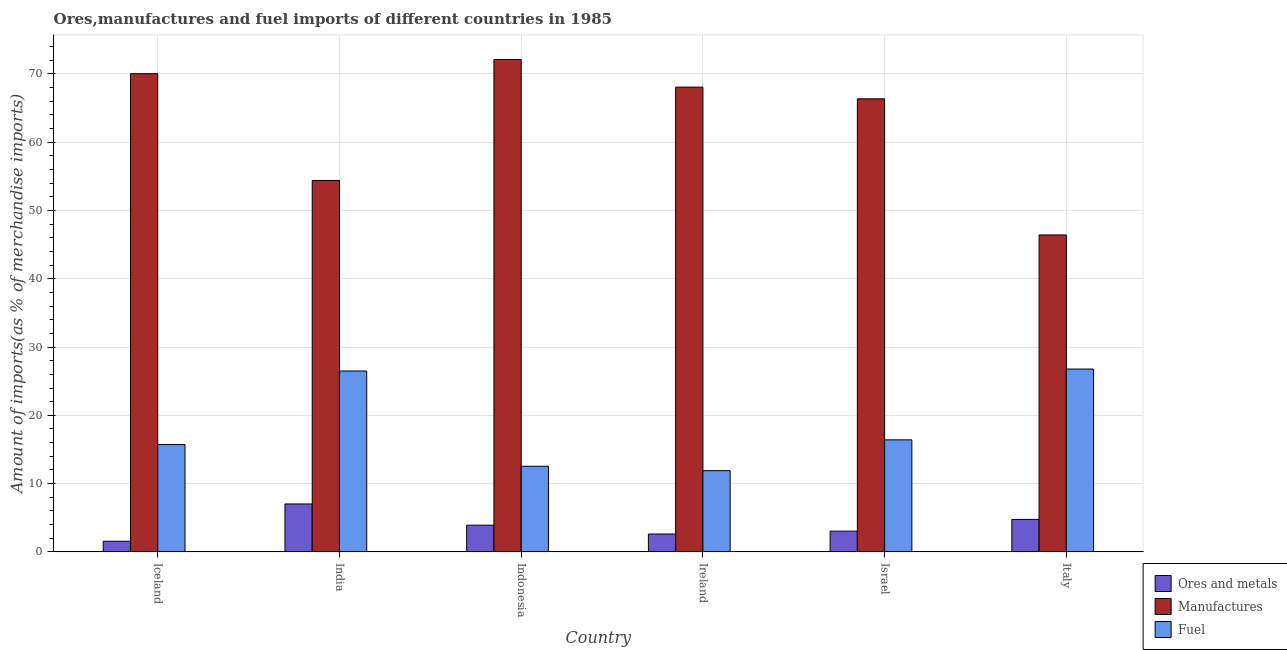How many different coloured bars are there?
Give a very brief answer. 3. Are the number of bars on each tick of the X-axis equal?
Ensure brevity in your answer.  Yes. How many bars are there on the 4th tick from the right?
Your response must be concise. 3. What is the label of the 6th group of bars from the left?
Ensure brevity in your answer.  Italy. What is the percentage of manufactures imports in India?
Your answer should be compact. 54.39. Across all countries, what is the maximum percentage of ores and metals imports?
Provide a succinct answer. 7.02. Across all countries, what is the minimum percentage of manufactures imports?
Your answer should be very brief. 46.41. In which country was the percentage of ores and metals imports maximum?
Offer a very short reply. India. In which country was the percentage of manufactures imports minimum?
Provide a succinct answer. Italy. What is the total percentage of manufactures imports in the graph?
Ensure brevity in your answer.  377.37. What is the difference between the percentage of manufactures imports in India and that in Indonesia?
Offer a very short reply. -17.72. What is the difference between the percentage of ores and metals imports in Italy and the percentage of fuel imports in India?
Your answer should be very brief. -21.74. What is the average percentage of manufactures imports per country?
Make the answer very short. 62.89. What is the difference between the percentage of manufactures imports and percentage of ores and metals imports in Indonesia?
Your answer should be very brief. 68.2. What is the ratio of the percentage of fuel imports in India to that in Indonesia?
Offer a very short reply. 2.11. Is the percentage of fuel imports in India less than that in Israel?
Your answer should be very brief. No. What is the difference between the highest and the second highest percentage of manufactures imports?
Your response must be concise. 2.08. What is the difference between the highest and the lowest percentage of manufactures imports?
Provide a succinct answer. 25.7. Is the sum of the percentage of ores and metals imports in Israel and Italy greater than the maximum percentage of manufactures imports across all countries?
Offer a terse response. No. What does the 3rd bar from the left in Iceland represents?
Make the answer very short. Fuel. What does the 1st bar from the right in Israel represents?
Provide a succinct answer. Fuel. Is it the case that in every country, the sum of the percentage of ores and metals imports and percentage of manufactures imports is greater than the percentage of fuel imports?
Offer a terse response. Yes. How many bars are there?
Offer a very short reply. 18. How many countries are there in the graph?
Ensure brevity in your answer.  6. What is the difference between two consecutive major ticks on the Y-axis?
Provide a short and direct response. 10. Are the values on the major ticks of Y-axis written in scientific E-notation?
Ensure brevity in your answer.  No. Does the graph contain any zero values?
Ensure brevity in your answer.  No. Does the graph contain grids?
Ensure brevity in your answer.  Yes. Where does the legend appear in the graph?
Offer a terse response. Bottom right. How are the legend labels stacked?
Keep it short and to the point. Vertical. What is the title of the graph?
Ensure brevity in your answer.  Ores,manufactures and fuel imports of different countries in 1985. What is the label or title of the X-axis?
Keep it short and to the point. Country. What is the label or title of the Y-axis?
Your response must be concise. Amount of imports(as % of merchandise imports). What is the Amount of imports(as % of merchandise imports) of Ores and metals in Iceland?
Your response must be concise. 1.56. What is the Amount of imports(as % of merchandise imports) in Manufactures in Iceland?
Make the answer very short. 70.03. What is the Amount of imports(as % of merchandise imports) in Fuel in Iceland?
Offer a terse response. 15.71. What is the Amount of imports(as % of merchandise imports) in Ores and metals in India?
Your answer should be compact. 7.02. What is the Amount of imports(as % of merchandise imports) in Manufactures in India?
Your answer should be compact. 54.39. What is the Amount of imports(as % of merchandise imports) of Fuel in India?
Your answer should be compact. 26.49. What is the Amount of imports(as % of merchandise imports) of Ores and metals in Indonesia?
Ensure brevity in your answer.  3.91. What is the Amount of imports(as % of merchandise imports) of Manufactures in Indonesia?
Your answer should be very brief. 72.11. What is the Amount of imports(as % of merchandise imports) of Fuel in Indonesia?
Offer a terse response. 12.54. What is the Amount of imports(as % of merchandise imports) of Ores and metals in Ireland?
Make the answer very short. 2.61. What is the Amount of imports(as % of merchandise imports) of Manufactures in Ireland?
Your response must be concise. 68.07. What is the Amount of imports(as % of merchandise imports) of Fuel in Ireland?
Provide a short and direct response. 11.89. What is the Amount of imports(as % of merchandise imports) of Ores and metals in Israel?
Offer a very short reply. 3.03. What is the Amount of imports(as % of merchandise imports) of Manufactures in Israel?
Your answer should be compact. 66.35. What is the Amount of imports(as % of merchandise imports) in Fuel in Israel?
Provide a succinct answer. 16.41. What is the Amount of imports(as % of merchandise imports) in Ores and metals in Italy?
Offer a very short reply. 4.75. What is the Amount of imports(as % of merchandise imports) of Manufactures in Italy?
Your answer should be compact. 46.41. What is the Amount of imports(as % of merchandise imports) in Fuel in Italy?
Provide a short and direct response. 26.78. Across all countries, what is the maximum Amount of imports(as % of merchandise imports) in Ores and metals?
Offer a terse response. 7.02. Across all countries, what is the maximum Amount of imports(as % of merchandise imports) in Manufactures?
Your response must be concise. 72.11. Across all countries, what is the maximum Amount of imports(as % of merchandise imports) of Fuel?
Ensure brevity in your answer.  26.78. Across all countries, what is the minimum Amount of imports(as % of merchandise imports) of Ores and metals?
Offer a terse response. 1.56. Across all countries, what is the minimum Amount of imports(as % of merchandise imports) in Manufactures?
Offer a terse response. 46.41. Across all countries, what is the minimum Amount of imports(as % of merchandise imports) of Fuel?
Make the answer very short. 11.89. What is the total Amount of imports(as % of merchandise imports) in Ores and metals in the graph?
Your answer should be compact. 22.89. What is the total Amount of imports(as % of merchandise imports) of Manufactures in the graph?
Keep it short and to the point. 377.37. What is the total Amount of imports(as % of merchandise imports) in Fuel in the graph?
Provide a short and direct response. 109.82. What is the difference between the Amount of imports(as % of merchandise imports) of Ores and metals in Iceland and that in India?
Your response must be concise. -5.46. What is the difference between the Amount of imports(as % of merchandise imports) in Manufactures in Iceland and that in India?
Your answer should be compact. 15.64. What is the difference between the Amount of imports(as % of merchandise imports) in Fuel in Iceland and that in India?
Offer a terse response. -10.78. What is the difference between the Amount of imports(as % of merchandise imports) of Ores and metals in Iceland and that in Indonesia?
Ensure brevity in your answer.  -2.35. What is the difference between the Amount of imports(as % of merchandise imports) in Manufactures in Iceland and that in Indonesia?
Provide a short and direct response. -2.08. What is the difference between the Amount of imports(as % of merchandise imports) of Fuel in Iceland and that in Indonesia?
Ensure brevity in your answer.  3.18. What is the difference between the Amount of imports(as % of merchandise imports) of Ores and metals in Iceland and that in Ireland?
Your answer should be very brief. -1.06. What is the difference between the Amount of imports(as % of merchandise imports) in Manufactures in Iceland and that in Ireland?
Ensure brevity in your answer.  1.96. What is the difference between the Amount of imports(as % of merchandise imports) in Fuel in Iceland and that in Ireland?
Offer a very short reply. 3.82. What is the difference between the Amount of imports(as % of merchandise imports) of Ores and metals in Iceland and that in Israel?
Make the answer very short. -1.48. What is the difference between the Amount of imports(as % of merchandise imports) of Manufactures in Iceland and that in Israel?
Your answer should be very brief. 3.68. What is the difference between the Amount of imports(as % of merchandise imports) of Fuel in Iceland and that in Israel?
Make the answer very short. -0.69. What is the difference between the Amount of imports(as % of merchandise imports) of Ores and metals in Iceland and that in Italy?
Provide a short and direct response. -3.2. What is the difference between the Amount of imports(as % of merchandise imports) in Manufactures in Iceland and that in Italy?
Provide a succinct answer. 23.62. What is the difference between the Amount of imports(as % of merchandise imports) in Fuel in Iceland and that in Italy?
Offer a terse response. -11.06. What is the difference between the Amount of imports(as % of merchandise imports) of Ores and metals in India and that in Indonesia?
Provide a succinct answer. 3.11. What is the difference between the Amount of imports(as % of merchandise imports) of Manufactures in India and that in Indonesia?
Make the answer very short. -17.72. What is the difference between the Amount of imports(as % of merchandise imports) in Fuel in India and that in Indonesia?
Give a very brief answer. 13.95. What is the difference between the Amount of imports(as % of merchandise imports) of Ores and metals in India and that in Ireland?
Offer a very short reply. 4.4. What is the difference between the Amount of imports(as % of merchandise imports) in Manufactures in India and that in Ireland?
Provide a succinct answer. -13.68. What is the difference between the Amount of imports(as % of merchandise imports) of Fuel in India and that in Ireland?
Ensure brevity in your answer.  14.6. What is the difference between the Amount of imports(as % of merchandise imports) of Ores and metals in India and that in Israel?
Your response must be concise. 3.98. What is the difference between the Amount of imports(as % of merchandise imports) of Manufactures in India and that in Israel?
Your answer should be compact. -11.96. What is the difference between the Amount of imports(as % of merchandise imports) in Fuel in India and that in Israel?
Ensure brevity in your answer.  10.09. What is the difference between the Amount of imports(as % of merchandise imports) in Ores and metals in India and that in Italy?
Offer a terse response. 2.26. What is the difference between the Amount of imports(as % of merchandise imports) of Manufactures in India and that in Italy?
Provide a succinct answer. 7.98. What is the difference between the Amount of imports(as % of merchandise imports) in Fuel in India and that in Italy?
Keep it short and to the point. -0.28. What is the difference between the Amount of imports(as % of merchandise imports) in Ores and metals in Indonesia and that in Ireland?
Your response must be concise. 1.3. What is the difference between the Amount of imports(as % of merchandise imports) of Manufactures in Indonesia and that in Ireland?
Keep it short and to the point. 4.04. What is the difference between the Amount of imports(as % of merchandise imports) in Fuel in Indonesia and that in Ireland?
Provide a succinct answer. 0.65. What is the difference between the Amount of imports(as % of merchandise imports) in Ores and metals in Indonesia and that in Israel?
Your answer should be very brief. 0.88. What is the difference between the Amount of imports(as % of merchandise imports) of Manufactures in Indonesia and that in Israel?
Offer a very short reply. 5.76. What is the difference between the Amount of imports(as % of merchandise imports) of Fuel in Indonesia and that in Israel?
Your response must be concise. -3.87. What is the difference between the Amount of imports(as % of merchandise imports) in Ores and metals in Indonesia and that in Italy?
Give a very brief answer. -0.84. What is the difference between the Amount of imports(as % of merchandise imports) in Manufactures in Indonesia and that in Italy?
Give a very brief answer. 25.7. What is the difference between the Amount of imports(as % of merchandise imports) of Fuel in Indonesia and that in Italy?
Provide a short and direct response. -14.24. What is the difference between the Amount of imports(as % of merchandise imports) in Ores and metals in Ireland and that in Israel?
Your response must be concise. -0.42. What is the difference between the Amount of imports(as % of merchandise imports) of Manufactures in Ireland and that in Israel?
Your answer should be very brief. 1.72. What is the difference between the Amount of imports(as % of merchandise imports) in Fuel in Ireland and that in Israel?
Ensure brevity in your answer.  -4.51. What is the difference between the Amount of imports(as % of merchandise imports) in Ores and metals in Ireland and that in Italy?
Keep it short and to the point. -2.14. What is the difference between the Amount of imports(as % of merchandise imports) of Manufactures in Ireland and that in Italy?
Your response must be concise. 21.65. What is the difference between the Amount of imports(as % of merchandise imports) of Fuel in Ireland and that in Italy?
Keep it short and to the point. -14.88. What is the difference between the Amount of imports(as % of merchandise imports) in Ores and metals in Israel and that in Italy?
Provide a short and direct response. -1.72. What is the difference between the Amount of imports(as % of merchandise imports) in Manufactures in Israel and that in Italy?
Your answer should be very brief. 19.94. What is the difference between the Amount of imports(as % of merchandise imports) in Fuel in Israel and that in Italy?
Your answer should be compact. -10.37. What is the difference between the Amount of imports(as % of merchandise imports) of Ores and metals in Iceland and the Amount of imports(as % of merchandise imports) of Manufactures in India?
Your answer should be very brief. -52.84. What is the difference between the Amount of imports(as % of merchandise imports) of Ores and metals in Iceland and the Amount of imports(as % of merchandise imports) of Fuel in India?
Provide a succinct answer. -24.94. What is the difference between the Amount of imports(as % of merchandise imports) in Manufactures in Iceland and the Amount of imports(as % of merchandise imports) in Fuel in India?
Make the answer very short. 43.54. What is the difference between the Amount of imports(as % of merchandise imports) of Ores and metals in Iceland and the Amount of imports(as % of merchandise imports) of Manufactures in Indonesia?
Your answer should be compact. -70.56. What is the difference between the Amount of imports(as % of merchandise imports) in Ores and metals in Iceland and the Amount of imports(as % of merchandise imports) in Fuel in Indonesia?
Provide a succinct answer. -10.98. What is the difference between the Amount of imports(as % of merchandise imports) of Manufactures in Iceland and the Amount of imports(as % of merchandise imports) of Fuel in Indonesia?
Ensure brevity in your answer.  57.49. What is the difference between the Amount of imports(as % of merchandise imports) in Ores and metals in Iceland and the Amount of imports(as % of merchandise imports) in Manufactures in Ireland?
Your answer should be very brief. -66.51. What is the difference between the Amount of imports(as % of merchandise imports) in Ores and metals in Iceland and the Amount of imports(as % of merchandise imports) in Fuel in Ireland?
Your answer should be very brief. -10.34. What is the difference between the Amount of imports(as % of merchandise imports) of Manufactures in Iceland and the Amount of imports(as % of merchandise imports) of Fuel in Ireland?
Keep it short and to the point. 58.14. What is the difference between the Amount of imports(as % of merchandise imports) in Ores and metals in Iceland and the Amount of imports(as % of merchandise imports) in Manufactures in Israel?
Your answer should be compact. -64.8. What is the difference between the Amount of imports(as % of merchandise imports) in Ores and metals in Iceland and the Amount of imports(as % of merchandise imports) in Fuel in Israel?
Provide a succinct answer. -14.85. What is the difference between the Amount of imports(as % of merchandise imports) in Manufactures in Iceland and the Amount of imports(as % of merchandise imports) in Fuel in Israel?
Ensure brevity in your answer.  53.62. What is the difference between the Amount of imports(as % of merchandise imports) in Ores and metals in Iceland and the Amount of imports(as % of merchandise imports) in Manufactures in Italy?
Make the answer very short. -44.86. What is the difference between the Amount of imports(as % of merchandise imports) in Ores and metals in Iceland and the Amount of imports(as % of merchandise imports) in Fuel in Italy?
Keep it short and to the point. -25.22. What is the difference between the Amount of imports(as % of merchandise imports) in Manufactures in Iceland and the Amount of imports(as % of merchandise imports) in Fuel in Italy?
Provide a short and direct response. 43.25. What is the difference between the Amount of imports(as % of merchandise imports) of Ores and metals in India and the Amount of imports(as % of merchandise imports) of Manufactures in Indonesia?
Your answer should be very brief. -65.09. What is the difference between the Amount of imports(as % of merchandise imports) in Ores and metals in India and the Amount of imports(as % of merchandise imports) in Fuel in Indonesia?
Your answer should be very brief. -5.52. What is the difference between the Amount of imports(as % of merchandise imports) in Manufactures in India and the Amount of imports(as % of merchandise imports) in Fuel in Indonesia?
Your response must be concise. 41.85. What is the difference between the Amount of imports(as % of merchandise imports) in Ores and metals in India and the Amount of imports(as % of merchandise imports) in Manufactures in Ireland?
Provide a short and direct response. -61.05. What is the difference between the Amount of imports(as % of merchandise imports) of Ores and metals in India and the Amount of imports(as % of merchandise imports) of Fuel in Ireland?
Provide a succinct answer. -4.88. What is the difference between the Amount of imports(as % of merchandise imports) in Manufactures in India and the Amount of imports(as % of merchandise imports) in Fuel in Ireland?
Keep it short and to the point. 42.5. What is the difference between the Amount of imports(as % of merchandise imports) of Ores and metals in India and the Amount of imports(as % of merchandise imports) of Manufactures in Israel?
Keep it short and to the point. -59.34. What is the difference between the Amount of imports(as % of merchandise imports) in Ores and metals in India and the Amount of imports(as % of merchandise imports) in Fuel in Israel?
Keep it short and to the point. -9.39. What is the difference between the Amount of imports(as % of merchandise imports) in Manufactures in India and the Amount of imports(as % of merchandise imports) in Fuel in Israel?
Offer a very short reply. 37.99. What is the difference between the Amount of imports(as % of merchandise imports) in Ores and metals in India and the Amount of imports(as % of merchandise imports) in Manufactures in Italy?
Offer a very short reply. -39.4. What is the difference between the Amount of imports(as % of merchandise imports) of Ores and metals in India and the Amount of imports(as % of merchandise imports) of Fuel in Italy?
Make the answer very short. -19.76. What is the difference between the Amount of imports(as % of merchandise imports) in Manufactures in India and the Amount of imports(as % of merchandise imports) in Fuel in Italy?
Provide a short and direct response. 27.62. What is the difference between the Amount of imports(as % of merchandise imports) of Ores and metals in Indonesia and the Amount of imports(as % of merchandise imports) of Manufactures in Ireland?
Offer a very short reply. -64.16. What is the difference between the Amount of imports(as % of merchandise imports) in Ores and metals in Indonesia and the Amount of imports(as % of merchandise imports) in Fuel in Ireland?
Provide a succinct answer. -7.98. What is the difference between the Amount of imports(as % of merchandise imports) of Manufactures in Indonesia and the Amount of imports(as % of merchandise imports) of Fuel in Ireland?
Your response must be concise. 60.22. What is the difference between the Amount of imports(as % of merchandise imports) of Ores and metals in Indonesia and the Amount of imports(as % of merchandise imports) of Manufactures in Israel?
Provide a short and direct response. -62.44. What is the difference between the Amount of imports(as % of merchandise imports) in Ores and metals in Indonesia and the Amount of imports(as % of merchandise imports) in Fuel in Israel?
Make the answer very short. -12.5. What is the difference between the Amount of imports(as % of merchandise imports) of Manufactures in Indonesia and the Amount of imports(as % of merchandise imports) of Fuel in Israel?
Ensure brevity in your answer.  55.71. What is the difference between the Amount of imports(as % of merchandise imports) in Ores and metals in Indonesia and the Amount of imports(as % of merchandise imports) in Manufactures in Italy?
Offer a terse response. -42.5. What is the difference between the Amount of imports(as % of merchandise imports) in Ores and metals in Indonesia and the Amount of imports(as % of merchandise imports) in Fuel in Italy?
Provide a succinct answer. -22.87. What is the difference between the Amount of imports(as % of merchandise imports) in Manufactures in Indonesia and the Amount of imports(as % of merchandise imports) in Fuel in Italy?
Your answer should be compact. 45.34. What is the difference between the Amount of imports(as % of merchandise imports) in Ores and metals in Ireland and the Amount of imports(as % of merchandise imports) in Manufactures in Israel?
Provide a succinct answer. -63.74. What is the difference between the Amount of imports(as % of merchandise imports) in Ores and metals in Ireland and the Amount of imports(as % of merchandise imports) in Fuel in Israel?
Offer a terse response. -13.79. What is the difference between the Amount of imports(as % of merchandise imports) of Manufactures in Ireland and the Amount of imports(as % of merchandise imports) of Fuel in Israel?
Ensure brevity in your answer.  51.66. What is the difference between the Amount of imports(as % of merchandise imports) of Ores and metals in Ireland and the Amount of imports(as % of merchandise imports) of Manufactures in Italy?
Your answer should be very brief. -43.8. What is the difference between the Amount of imports(as % of merchandise imports) in Ores and metals in Ireland and the Amount of imports(as % of merchandise imports) in Fuel in Italy?
Offer a very short reply. -24.16. What is the difference between the Amount of imports(as % of merchandise imports) in Manufactures in Ireland and the Amount of imports(as % of merchandise imports) in Fuel in Italy?
Your response must be concise. 41.29. What is the difference between the Amount of imports(as % of merchandise imports) in Ores and metals in Israel and the Amount of imports(as % of merchandise imports) in Manufactures in Italy?
Ensure brevity in your answer.  -43.38. What is the difference between the Amount of imports(as % of merchandise imports) in Ores and metals in Israel and the Amount of imports(as % of merchandise imports) in Fuel in Italy?
Offer a terse response. -23.74. What is the difference between the Amount of imports(as % of merchandise imports) of Manufactures in Israel and the Amount of imports(as % of merchandise imports) of Fuel in Italy?
Keep it short and to the point. 39.58. What is the average Amount of imports(as % of merchandise imports) in Ores and metals per country?
Give a very brief answer. 3.81. What is the average Amount of imports(as % of merchandise imports) of Manufactures per country?
Ensure brevity in your answer.  62.89. What is the average Amount of imports(as % of merchandise imports) of Fuel per country?
Provide a succinct answer. 18.3. What is the difference between the Amount of imports(as % of merchandise imports) of Ores and metals and Amount of imports(as % of merchandise imports) of Manufactures in Iceland?
Give a very brief answer. -68.47. What is the difference between the Amount of imports(as % of merchandise imports) of Ores and metals and Amount of imports(as % of merchandise imports) of Fuel in Iceland?
Offer a very short reply. -14.16. What is the difference between the Amount of imports(as % of merchandise imports) of Manufactures and Amount of imports(as % of merchandise imports) of Fuel in Iceland?
Your answer should be compact. 54.31. What is the difference between the Amount of imports(as % of merchandise imports) in Ores and metals and Amount of imports(as % of merchandise imports) in Manufactures in India?
Provide a succinct answer. -47.38. What is the difference between the Amount of imports(as % of merchandise imports) of Ores and metals and Amount of imports(as % of merchandise imports) of Fuel in India?
Provide a succinct answer. -19.47. What is the difference between the Amount of imports(as % of merchandise imports) in Manufactures and Amount of imports(as % of merchandise imports) in Fuel in India?
Keep it short and to the point. 27.9. What is the difference between the Amount of imports(as % of merchandise imports) in Ores and metals and Amount of imports(as % of merchandise imports) in Manufactures in Indonesia?
Provide a succinct answer. -68.2. What is the difference between the Amount of imports(as % of merchandise imports) in Ores and metals and Amount of imports(as % of merchandise imports) in Fuel in Indonesia?
Provide a succinct answer. -8.63. What is the difference between the Amount of imports(as % of merchandise imports) of Manufactures and Amount of imports(as % of merchandise imports) of Fuel in Indonesia?
Provide a short and direct response. 59.57. What is the difference between the Amount of imports(as % of merchandise imports) of Ores and metals and Amount of imports(as % of merchandise imports) of Manufactures in Ireland?
Your response must be concise. -65.45. What is the difference between the Amount of imports(as % of merchandise imports) of Ores and metals and Amount of imports(as % of merchandise imports) of Fuel in Ireland?
Your response must be concise. -9.28. What is the difference between the Amount of imports(as % of merchandise imports) of Manufactures and Amount of imports(as % of merchandise imports) of Fuel in Ireland?
Keep it short and to the point. 56.18. What is the difference between the Amount of imports(as % of merchandise imports) of Ores and metals and Amount of imports(as % of merchandise imports) of Manufactures in Israel?
Provide a short and direct response. -63.32. What is the difference between the Amount of imports(as % of merchandise imports) of Ores and metals and Amount of imports(as % of merchandise imports) of Fuel in Israel?
Your response must be concise. -13.37. What is the difference between the Amount of imports(as % of merchandise imports) of Manufactures and Amount of imports(as % of merchandise imports) of Fuel in Israel?
Offer a very short reply. 49.95. What is the difference between the Amount of imports(as % of merchandise imports) in Ores and metals and Amount of imports(as % of merchandise imports) in Manufactures in Italy?
Your answer should be compact. -41.66. What is the difference between the Amount of imports(as % of merchandise imports) of Ores and metals and Amount of imports(as % of merchandise imports) of Fuel in Italy?
Offer a very short reply. -22.02. What is the difference between the Amount of imports(as % of merchandise imports) of Manufactures and Amount of imports(as % of merchandise imports) of Fuel in Italy?
Keep it short and to the point. 19.64. What is the ratio of the Amount of imports(as % of merchandise imports) of Ores and metals in Iceland to that in India?
Keep it short and to the point. 0.22. What is the ratio of the Amount of imports(as % of merchandise imports) of Manufactures in Iceland to that in India?
Ensure brevity in your answer.  1.29. What is the ratio of the Amount of imports(as % of merchandise imports) in Fuel in Iceland to that in India?
Keep it short and to the point. 0.59. What is the ratio of the Amount of imports(as % of merchandise imports) of Ores and metals in Iceland to that in Indonesia?
Your answer should be very brief. 0.4. What is the ratio of the Amount of imports(as % of merchandise imports) of Manufactures in Iceland to that in Indonesia?
Keep it short and to the point. 0.97. What is the ratio of the Amount of imports(as % of merchandise imports) of Fuel in Iceland to that in Indonesia?
Make the answer very short. 1.25. What is the ratio of the Amount of imports(as % of merchandise imports) of Ores and metals in Iceland to that in Ireland?
Your answer should be compact. 0.6. What is the ratio of the Amount of imports(as % of merchandise imports) in Manufactures in Iceland to that in Ireland?
Ensure brevity in your answer.  1.03. What is the ratio of the Amount of imports(as % of merchandise imports) of Fuel in Iceland to that in Ireland?
Make the answer very short. 1.32. What is the ratio of the Amount of imports(as % of merchandise imports) in Ores and metals in Iceland to that in Israel?
Offer a terse response. 0.51. What is the ratio of the Amount of imports(as % of merchandise imports) of Manufactures in Iceland to that in Israel?
Ensure brevity in your answer.  1.06. What is the ratio of the Amount of imports(as % of merchandise imports) of Fuel in Iceland to that in Israel?
Make the answer very short. 0.96. What is the ratio of the Amount of imports(as % of merchandise imports) of Ores and metals in Iceland to that in Italy?
Provide a succinct answer. 0.33. What is the ratio of the Amount of imports(as % of merchandise imports) in Manufactures in Iceland to that in Italy?
Provide a succinct answer. 1.51. What is the ratio of the Amount of imports(as % of merchandise imports) of Fuel in Iceland to that in Italy?
Give a very brief answer. 0.59. What is the ratio of the Amount of imports(as % of merchandise imports) of Ores and metals in India to that in Indonesia?
Your response must be concise. 1.79. What is the ratio of the Amount of imports(as % of merchandise imports) in Manufactures in India to that in Indonesia?
Your response must be concise. 0.75. What is the ratio of the Amount of imports(as % of merchandise imports) of Fuel in India to that in Indonesia?
Ensure brevity in your answer.  2.11. What is the ratio of the Amount of imports(as % of merchandise imports) of Ores and metals in India to that in Ireland?
Offer a terse response. 2.68. What is the ratio of the Amount of imports(as % of merchandise imports) of Manufactures in India to that in Ireland?
Your answer should be compact. 0.8. What is the ratio of the Amount of imports(as % of merchandise imports) of Fuel in India to that in Ireland?
Offer a terse response. 2.23. What is the ratio of the Amount of imports(as % of merchandise imports) in Ores and metals in India to that in Israel?
Give a very brief answer. 2.31. What is the ratio of the Amount of imports(as % of merchandise imports) of Manufactures in India to that in Israel?
Your answer should be compact. 0.82. What is the ratio of the Amount of imports(as % of merchandise imports) of Fuel in India to that in Israel?
Keep it short and to the point. 1.61. What is the ratio of the Amount of imports(as % of merchandise imports) in Ores and metals in India to that in Italy?
Your answer should be compact. 1.48. What is the ratio of the Amount of imports(as % of merchandise imports) of Manufactures in India to that in Italy?
Offer a very short reply. 1.17. What is the ratio of the Amount of imports(as % of merchandise imports) of Fuel in India to that in Italy?
Your response must be concise. 0.99. What is the ratio of the Amount of imports(as % of merchandise imports) of Ores and metals in Indonesia to that in Ireland?
Offer a terse response. 1.5. What is the ratio of the Amount of imports(as % of merchandise imports) in Manufactures in Indonesia to that in Ireland?
Your answer should be very brief. 1.06. What is the ratio of the Amount of imports(as % of merchandise imports) of Fuel in Indonesia to that in Ireland?
Offer a terse response. 1.05. What is the ratio of the Amount of imports(as % of merchandise imports) of Ores and metals in Indonesia to that in Israel?
Offer a very short reply. 1.29. What is the ratio of the Amount of imports(as % of merchandise imports) of Manufactures in Indonesia to that in Israel?
Offer a very short reply. 1.09. What is the ratio of the Amount of imports(as % of merchandise imports) of Fuel in Indonesia to that in Israel?
Offer a terse response. 0.76. What is the ratio of the Amount of imports(as % of merchandise imports) in Ores and metals in Indonesia to that in Italy?
Your answer should be very brief. 0.82. What is the ratio of the Amount of imports(as % of merchandise imports) in Manufactures in Indonesia to that in Italy?
Offer a very short reply. 1.55. What is the ratio of the Amount of imports(as % of merchandise imports) in Fuel in Indonesia to that in Italy?
Ensure brevity in your answer.  0.47. What is the ratio of the Amount of imports(as % of merchandise imports) of Ores and metals in Ireland to that in Israel?
Offer a terse response. 0.86. What is the ratio of the Amount of imports(as % of merchandise imports) of Manufactures in Ireland to that in Israel?
Your response must be concise. 1.03. What is the ratio of the Amount of imports(as % of merchandise imports) in Fuel in Ireland to that in Israel?
Your answer should be very brief. 0.72. What is the ratio of the Amount of imports(as % of merchandise imports) in Ores and metals in Ireland to that in Italy?
Make the answer very short. 0.55. What is the ratio of the Amount of imports(as % of merchandise imports) of Manufactures in Ireland to that in Italy?
Keep it short and to the point. 1.47. What is the ratio of the Amount of imports(as % of merchandise imports) of Fuel in Ireland to that in Italy?
Offer a terse response. 0.44. What is the ratio of the Amount of imports(as % of merchandise imports) of Ores and metals in Israel to that in Italy?
Provide a succinct answer. 0.64. What is the ratio of the Amount of imports(as % of merchandise imports) in Manufactures in Israel to that in Italy?
Your answer should be very brief. 1.43. What is the ratio of the Amount of imports(as % of merchandise imports) in Fuel in Israel to that in Italy?
Make the answer very short. 0.61. What is the difference between the highest and the second highest Amount of imports(as % of merchandise imports) of Ores and metals?
Give a very brief answer. 2.26. What is the difference between the highest and the second highest Amount of imports(as % of merchandise imports) in Manufactures?
Provide a short and direct response. 2.08. What is the difference between the highest and the second highest Amount of imports(as % of merchandise imports) in Fuel?
Offer a very short reply. 0.28. What is the difference between the highest and the lowest Amount of imports(as % of merchandise imports) of Ores and metals?
Your answer should be very brief. 5.46. What is the difference between the highest and the lowest Amount of imports(as % of merchandise imports) in Manufactures?
Your answer should be compact. 25.7. What is the difference between the highest and the lowest Amount of imports(as % of merchandise imports) in Fuel?
Offer a terse response. 14.88. 